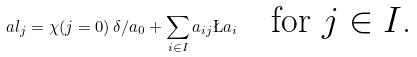<formula> <loc_0><loc_0><loc_500><loc_500>\ a l _ { j } = \chi ( j = 0 ) \, \delta / a _ { 0 } + \sum _ { i \in I } a _ { i j } \L a _ { i } \quad \text {for $j\in I$.}</formula> 